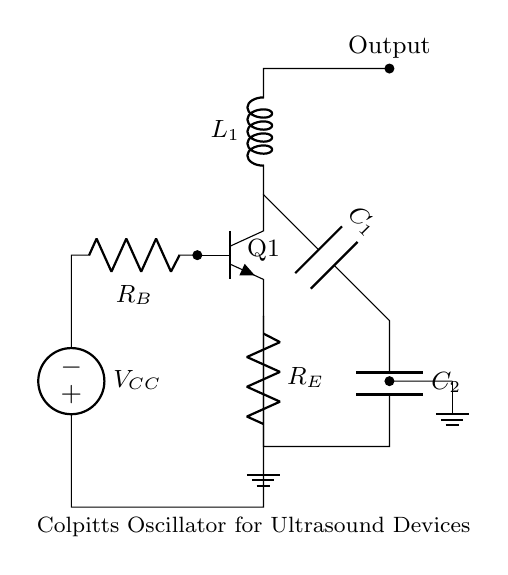What is the role of the inductor in this circuit? The inductor, labeled L1, is a key component in the Colpitts oscillator that helps determine the oscillation frequency along with the capacitors C1 and C2. Its presence in the feedback loop allows for energy storage in the magnetic field, which is essential for sustaining oscillations.
Answer: energy storage What does the notation VCC represent in this circuit? VCC denotes the power supply voltage for the circuit. It powers the transistor Q1 which is crucial for amplifying the signals and sustaining oscillations in the oscillator circuit.
Answer: power supply voltage How many capacitors are present in this circuit? There are two capacitors, labeled C1 and C2, which form part of the feedback network along with the inductor L1 and are essential for determining the oscillation frequency.
Answer: two What type of transistor is used in this Colpitts oscillator? The transistor Q1 is an NPN type, as denoted by the npn label, which is commonly used in oscillator circuits for its amplification properties.
Answer: NPN How do the resistors contribute to this circuit? The resistors, R_B and R_E, are used for biasing the transistor Q1. R_B provides the base biasing to turn on the transistor, while R_E helps stabilize the operating point and controls the emitter current, contributing to the stability of the oscillator's output.
Answer: biasing and stability What determines the frequency of oscillation in this circuit? The frequency of oscillation is determined by the values of the inductance (L1) and the capacitances (C1 and C2) in the feedback loop. The specific frequency can be calculated using the formula for a Colpitts oscillator, frequently expressed as f = 1 / (2π√(L*C)), where C is the equivalent capacitance of C1 and C2.
Answer: L and C values 